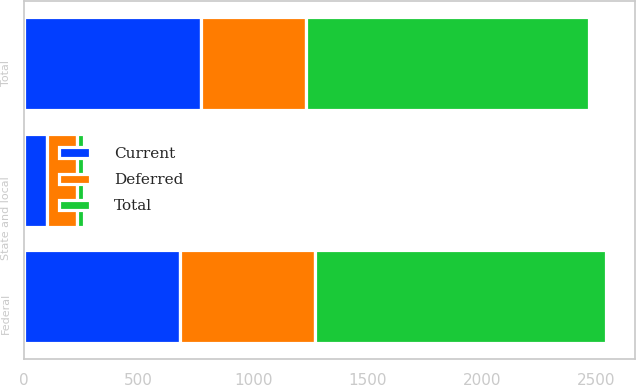Convert chart to OTSL. <chart><loc_0><loc_0><loc_500><loc_500><stacked_bar_chart><ecel><fcel>Federal<fcel>State and local<fcel>Total<nl><fcel>Current<fcel>681<fcel>98<fcel>773<nl><fcel>Total<fcel>1270<fcel>33<fcel>1233<nl><fcel>Deferred<fcel>589<fcel>131<fcel>460<nl></chart> 